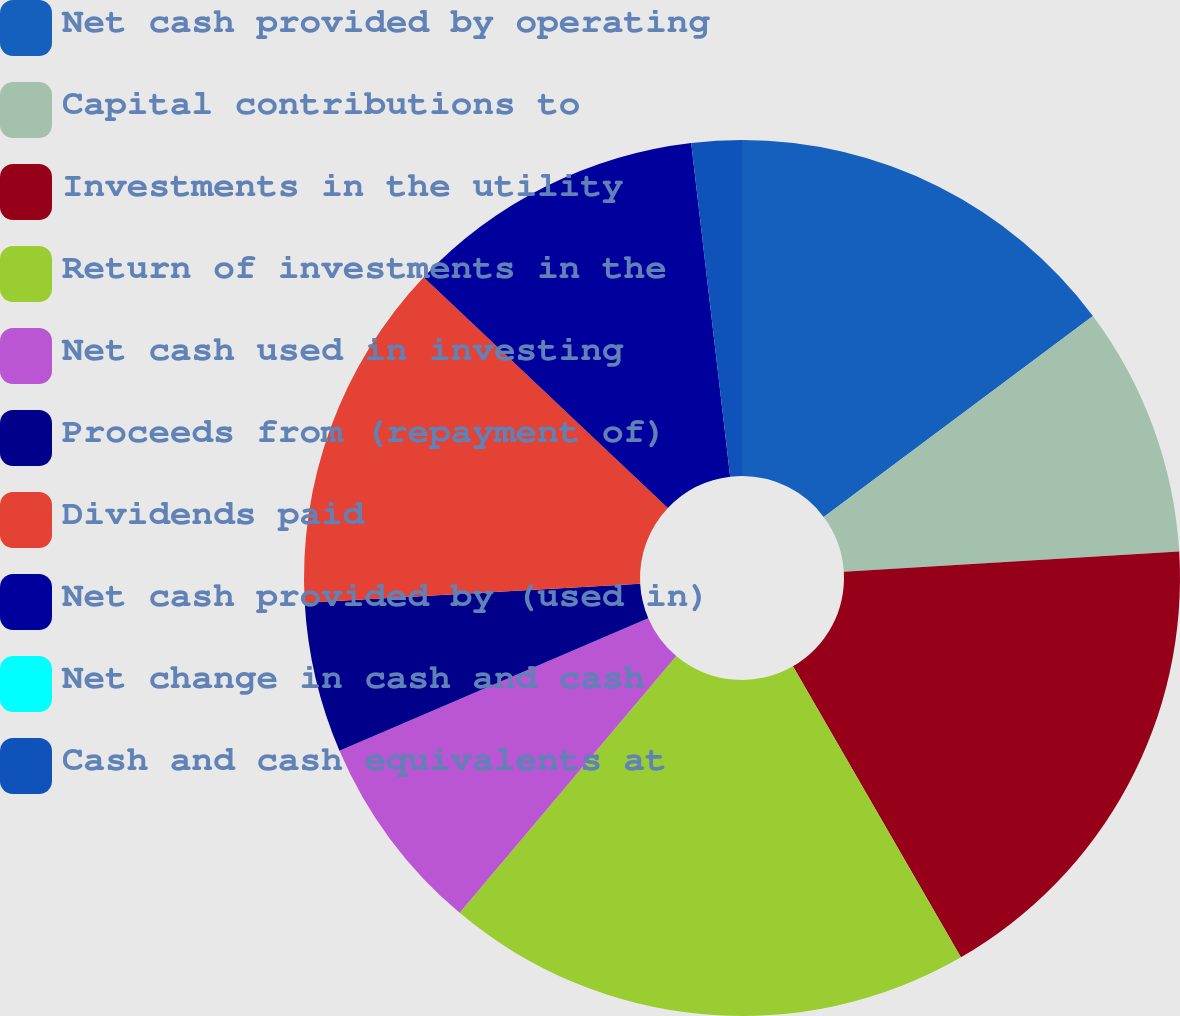Convert chart to OTSL. <chart><loc_0><loc_0><loc_500><loc_500><pie_chart><fcel>Net cash provided by operating<fcel>Capital contributions to<fcel>Investments in the utility<fcel>Return of investments in the<fcel>Net cash used in investing<fcel>Proceeds from (repayment of)<fcel>Dividends paid<fcel>Net cash provided by (used in)<fcel>Net change in cash and cash<fcel>Cash and cash equivalents at<nl><fcel>14.79%<fcel>9.25%<fcel>17.63%<fcel>19.48%<fcel>7.4%<fcel>5.55%<fcel>12.95%<fcel>11.1%<fcel>0.0%<fcel>1.85%<nl></chart> 